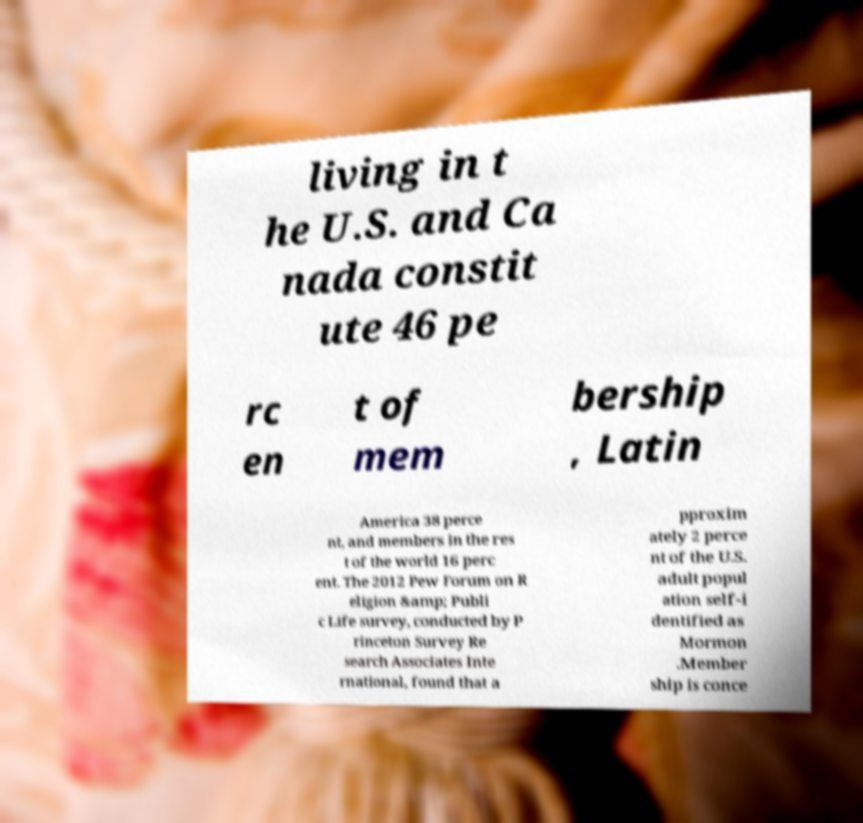For documentation purposes, I need the text within this image transcribed. Could you provide that? living in t he U.S. and Ca nada constit ute 46 pe rc en t of mem bership , Latin America 38 perce nt, and members in the res t of the world 16 perc ent. The 2012 Pew Forum on R eligion &amp; Publi c Life survey, conducted by P rinceton Survey Re search Associates Inte rnational, found that a pproxim ately 2 perce nt of the U.S. adult popul ation self-i dentified as Mormon .Member ship is conce 